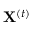<formula> <loc_0><loc_0><loc_500><loc_500>X ^ { ( t ) }</formula> 